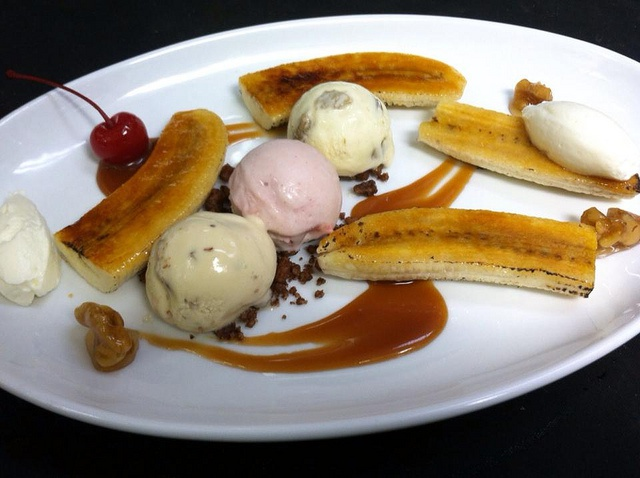Describe the objects in this image and their specific colors. I can see banana in black, olive, orange, and tan tones, banana in black, olive, maroon, and tan tones, banana in black, red, maroon, orange, and tan tones, banana in black, orange, tan, and olive tones, and banana in black, white, and tan tones in this image. 